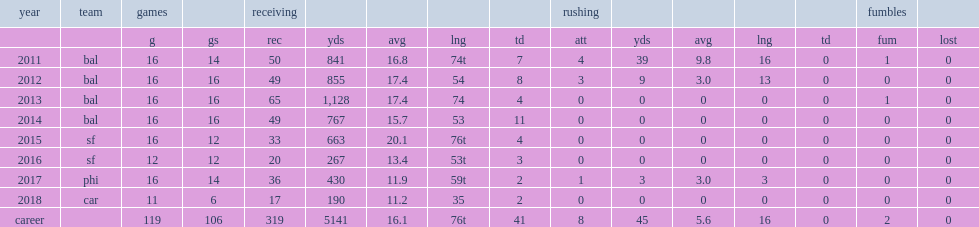Could you parse the entire table? {'header': ['year', 'team', 'games', '', 'receiving', '', '', '', '', 'rushing', '', '', '', '', 'fumbles', ''], 'rows': [['', '', 'g', 'gs', 'rec', 'yds', 'avg', 'lng', 'td', 'att', 'yds', 'avg', 'lng', 'td', 'fum', 'lost'], ['2011', 'bal', '16', '14', '50', '841', '16.8', '74t', '7', '4', '39', '9.8', '16', '0', '1', '0'], ['2012', 'bal', '16', '16', '49', '855', '17.4', '54', '8', '3', '9', '3.0', '13', '0', '0', '0'], ['2013', 'bal', '16', '16', '65', '1,128', '17.4', '74', '4', '0', '0', '0', '0', '0', '1', '0'], ['2014', 'bal', '16', '16', '49', '767', '15.7', '53', '11', '0', '0', '0', '0', '0', '0', '0'], ['2015', 'sf', '16', '12', '33', '663', '20.1', '76t', '4', '0', '0', '0', '0', '0', '0', '0'], ['2016', 'sf', '12', '12', '20', '267', '13.4', '53t', '3', '0', '0', '0', '0', '0', '0', '0'], ['2017', 'phi', '16', '14', '36', '430', '11.9', '59t', '2', '1', '3', '3.0', '3', '0', '0', '0'], ['2018', 'car', '11', '6', '17', '190', '11.2', '35', '2', '0', '0', '0', '0', '0', '0', '0'], ['career', '', '119', '106', '319', '5141', '16.1', '76t', '41', '8', '45', '5.6', '16', '0', '2', '0']]} How many receptions did smith finish the year with? 65.0. How many yards did smith finish the year with? 1128.0. How many touchdowns did smith finish the year with? 4.0. 